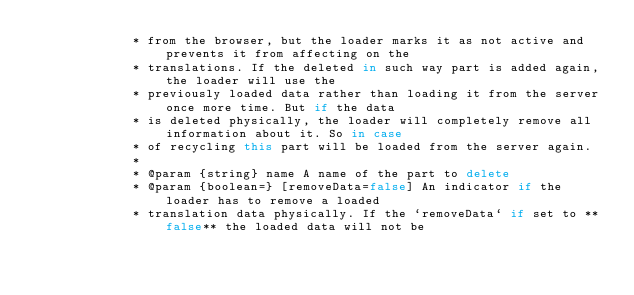Convert code to text. <code><loc_0><loc_0><loc_500><loc_500><_JavaScript_>             * from the browser, but the loader marks it as not active and prevents it from affecting on the
             * translations. If the deleted in such way part is added again, the loader will use the
             * previously loaded data rather than loading it from the server once more time. But if the data
             * is deleted physically, the loader will completely remove all information about it. So in case
             * of recycling this part will be loaded from the server again.
             *
             * @param {string} name A name of the part to delete
             * @param {boolean=} [removeData=false] An indicator if the loader has to remove a loaded
             * translation data physically. If the `removeData` if set to **false** the loaded data will not be</code> 